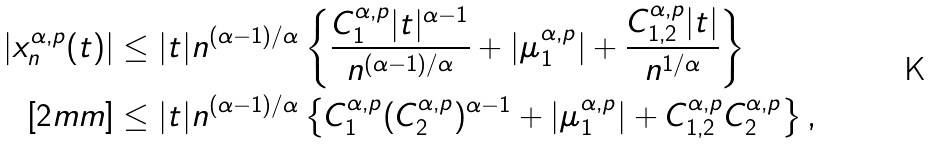Convert formula to latex. <formula><loc_0><loc_0><loc_500><loc_500>| x _ { n } ^ { \alpha , p } ( t ) | & \leq | t | n ^ { ( \alpha - 1 ) / \alpha } \left \{ \frac { C _ { 1 } ^ { \alpha , p } | t | ^ { \alpha - 1 } } { n ^ { ( \alpha - 1 ) / \alpha } } + | \mu _ { 1 } ^ { \alpha , p } | + \frac { C _ { 1 , 2 } ^ { \alpha , p } | t | } { n ^ { 1 / \alpha } } \right \} \\ [ 2 m m ] & \leq | t | n ^ { ( \alpha - 1 ) / \alpha } \left \{ C _ { 1 } ^ { \alpha , p } ( C _ { 2 } ^ { \alpha , p } ) ^ { \alpha - 1 } + | \mu _ { 1 } ^ { \alpha , p } | + C _ { 1 , 2 } ^ { \alpha , p } C _ { 2 } ^ { \alpha , p } \right \} ,</formula> 